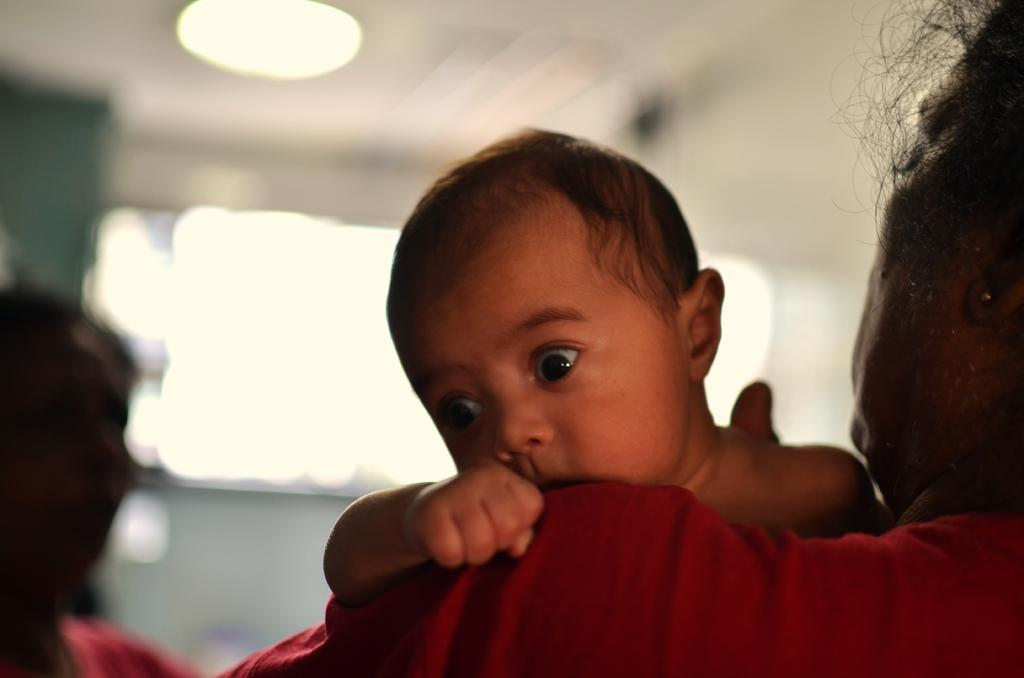What is the woman in the image doing? The woman is carrying a baby in the image. Can you describe the other woman in the image? There is another woman on the left side of the image. What can be said about the background of the image? The background of the image is blurry. What type of throne is the baby sitting on in the image? There is no throne present in the image; the baby is being carried by the woman. 